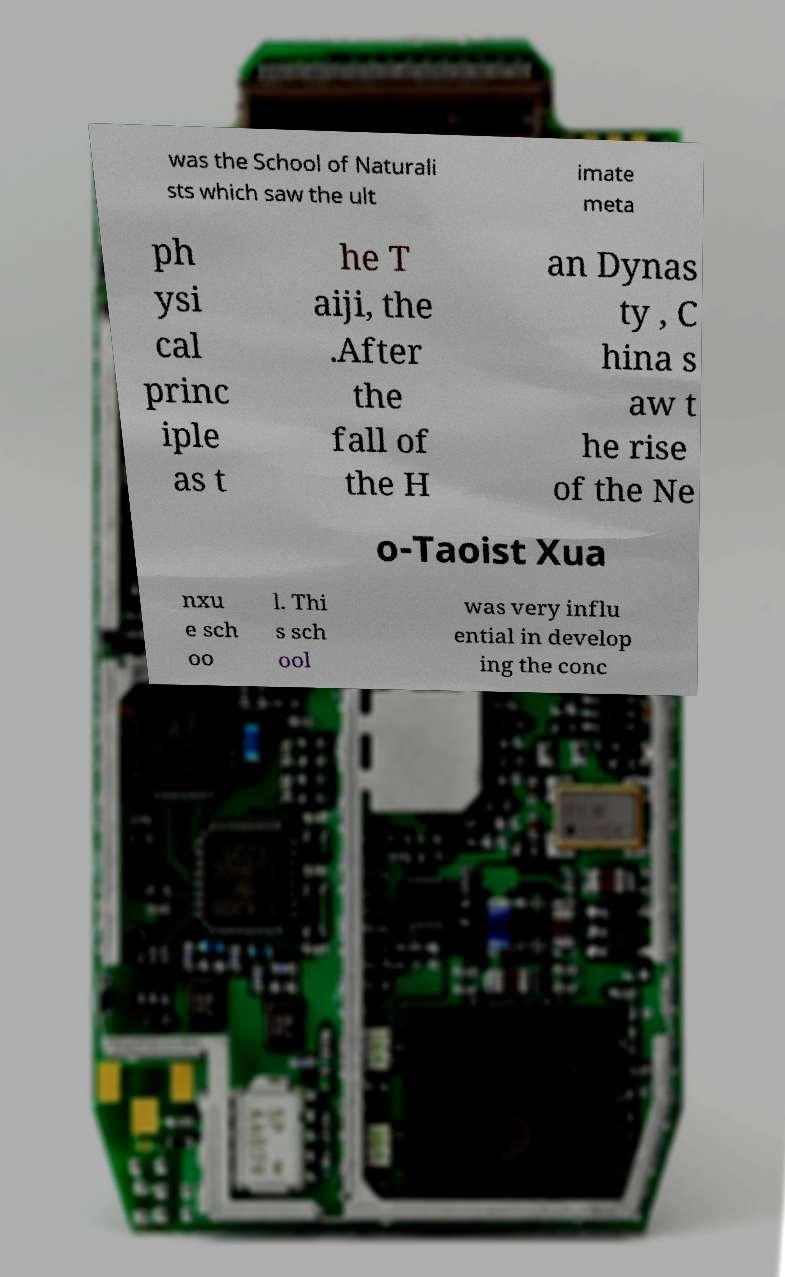For documentation purposes, I need the text within this image transcribed. Could you provide that? was the School of Naturali sts which saw the ult imate meta ph ysi cal princ iple as t he T aiji, the .After the fall of the H an Dynas ty , C hina s aw t he rise of the Ne o-Taoist Xua nxu e sch oo l. Thi s sch ool was very influ ential in develop ing the conc 